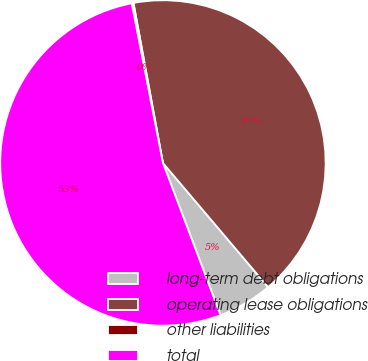Convert chart. <chart><loc_0><loc_0><loc_500><loc_500><pie_chart><fcel>long-term debt obligations<fcel>operating lease obligations<fcel>other liabilities<fcel>total<nl><fcel>5.43%<fcel>41.71%<fcel>0.18%<fcel>52.68%<nl></chart> 